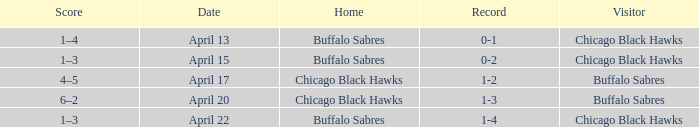Parse the full table. {'header': ['Score', 'Date', 'Home', 'Record', 'Visitor'], 'rows': [['1–4', 'April 13', 'Buffalo Sabres', '0-1', 'Chicago Black Hawks'], ['1–3', 'April 15', 'Buffalo Sabres', '0-2', 'Chicago Black Hawks'], ['4–5', 'April 17', 'Chicago Black Hawks', '1-2', 'Buffalo Sabres'], ['6–2', 'April 20', 'Chicago Black Hawks', '1-3', 'Buffalo Sabres'], ['1–3', 'April 22', 'Buffalo Sabres', '1-4', 'Chicago Black Hawks']]} Which Score has a Record of 0-1? 1–4. 